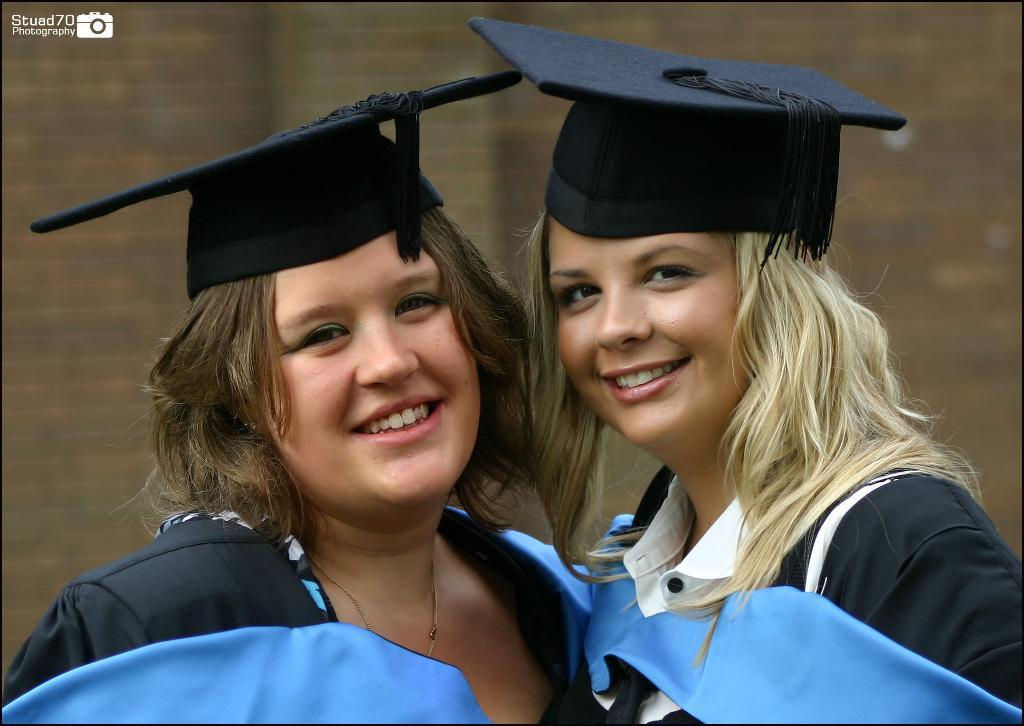How many people are in the image? There are two girls in the image. What are the girls wearing on their heads? The girls are wearing caps. Who are the girls looking at? The girls are looking at someone. What type of feast are the girls preparing in the image? There is no indication of a feast or any food preparation in the image. Who is the friend that the girls are talking to in the image? The image does not show the girls talking to a friend; they are simply looking at someone. 